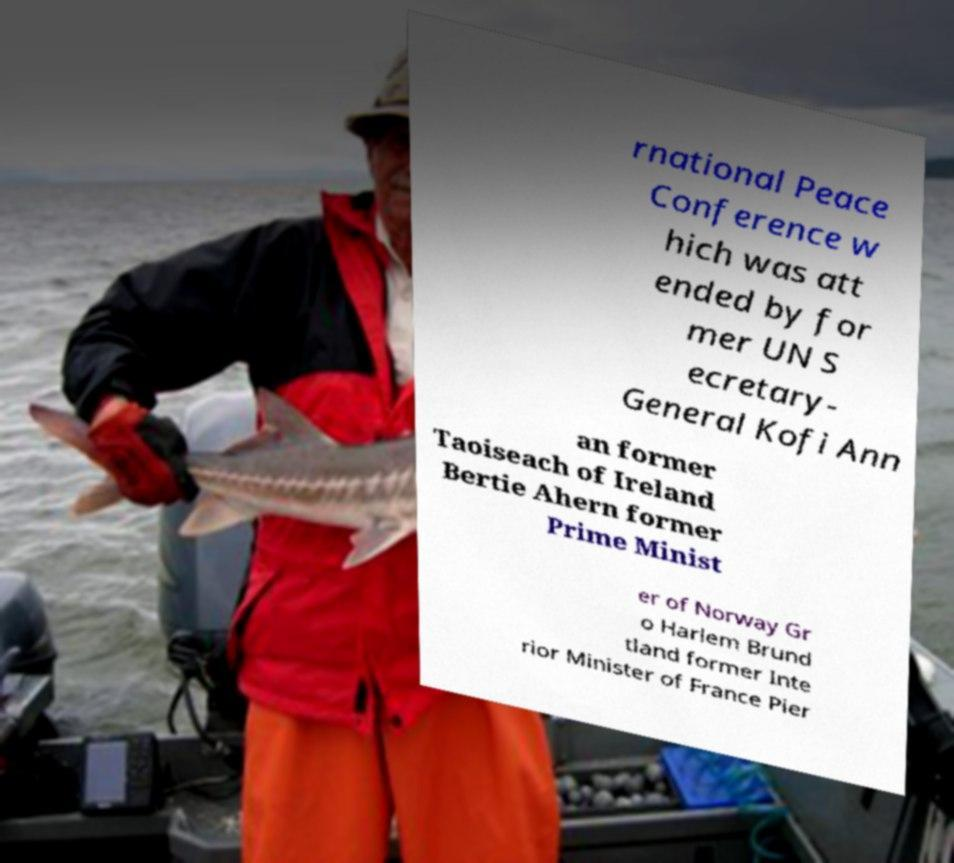There's text embedded in this image that I need extracted. Can you transcribe it verbatim? rnational Peace Conference w hich was att ended by for mer UN S ecretary- General Kofi Ann an former Taoiseach of Ireland Bertie Ahern former Prime Minist er of Norway Gr o Harlem Brund tland former Inte rior Minister of France Pier 